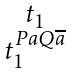Convert formula to latex. <formula><loc_0><loc_0><loc_500><loc_500>\begin{smallmatrix} t _ { 1 } \\ t _ { 1 } ^ { P a Q \overline { a } } \end{smallmatrix}</formula> 